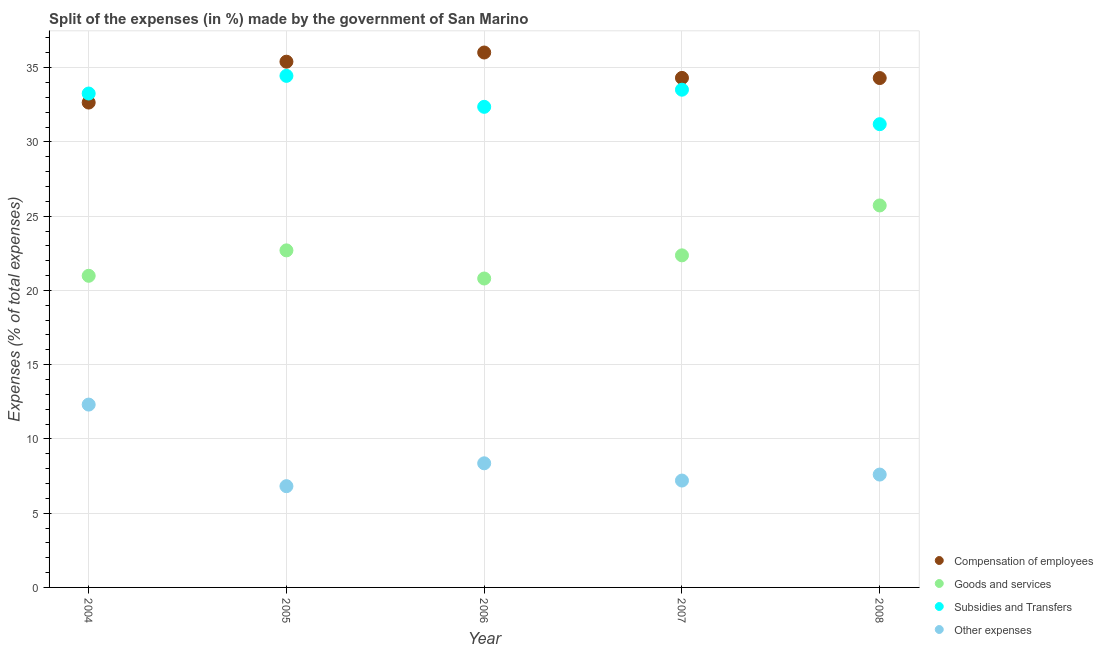How many different coloured dotlines are there?
Provide a succinct answer. 4. Is the number of dotlines equal to the number of legend labels?
Your answer should be very brief. Yes. What is the percentage of amount spent on goods and services in 2008?
Your answer should be very brief. 25.72. Across all years, what is the maximum percentage of amount spent on subsidies?
Ensure brevity in your answer.  34.45. Across all years, what is the minimum percentage of amount spent on subsidies?
Offer a terse response. 31.19. In which year was the percentage of amount spent on other expenses maximum?
Offer a terse response. 2004. What is the total percentage of amount spent on compensation of employees in the graph?
Your answer should be very brief. 172.68. What is the difference between the percentage of amount spent on goods and services in 2006 and that in 2007?
Your answer should be very brief. -1.56. What is the difference between the percentage of amount spent on other expenses in 2004 and the percentage of amount spent on compensation of employees in 2005?
Ensure brevity in your answer.  -23.09. What is the average percentage of amount spent on other expenses per year?
Offer a very short reply. 8.46. In the year 2006, what is the difference between the percentage of amount spent on subsidies and percentage of amount spent on compensation of employees?
Offer a terse response. -3.66. What is the ratio of the percentage of amount spent on compensation of employees in 2007 to that in 2008?
Give a very brief answer. 1. Is the percentage of amount spent on goods and services in 2005 less than that in 2008?
Offer a very short reply. Yes. Is the difference between the percentage of amount spent on other expenses in 2004 and 2007 greater than the difference between the percentage of amount spent on subsidies in 2004 and 2007?
Your answer should be very brief. Yes. What is the difference between the highest and the second highest percentage of amount spent on compensation of employees?
Give a very brief answer. 0.62. What is the difference between the highest and the lowest percentage of amount spent on other expenses?
Offer a terse response. 5.49. Is the sum of the percentage of amount spent on compensation of employees in 2005 and 2006 greater than the maximum percentage of amount spent on goods and services across all years?
Ensure brevity in your answer.  Yes. Is it the case that in every year, the sum of the percentage of amount spent on other expenses and percentage of amount spent on subsidies is greater than the sum of percentage of amount spent on goods and services and percentage of amount spent on compensation of employees?
Keep it short and to the point. No. Does the percentage of amount spent on other expenses monotonically increase over the years?
Keep it short and to the point. No. Is the percentage of amount spent on goods and services strictly greater than the percentage of amount spent on subsidies over the years?
Provide a short and direct response. No. Is the percentage of amount spent on goods and services strictly less than the percentage of amount spent on other expenses over the years?
Offer a terse response. No. Are the values on the major ticks of Y-axis written in scientific E-notation?
Your answer should be compact. No. Does the graph contain any zero values?
Offer a very short reply. No. Does the graph contain grids?
Keep it short and to the point. Yes. What is the title of the graph?
Your answer should be compact. Split of the expenses (in %) made by the government of San Marino. What is the label or title of the X-axis?
Your answer should be very brief. Year. What is the label or title of the Y-axis?
Your answer should be compact. Expenses (% of total expenses). What is the Expenses (% of total expenses) of Compensation of employees in 2004?
Offer a very short reply. 32.65. What is the Expenses (% of total expenses) of Goods and services in 2004?
Your answer should be compact. 20.98. What is the Expenses (% of total expenses) of Subsidies and Transfers in 2004?
Offer a terse response. 33.26. What is the Expenses (% of total expenses) of Other expenses in 2004?
Your answer should be very brief. 12.31. What is the Expenses (% of total expenses) in Compensation of employees in 2005?
Make the answer very short. 35.4. What is the Expenses (% of total expenses) in Goods and services in 2005?
Provide a succinct answer. 22.7. What is the Expenses (% of total expenses) in Subsidies and Transfers in 2005?
Offer a terse response. 34.45. What is the Expenses (% of total expenses) of Other expenses in 2005?
Your response must be concise. 6.82. What is the Expenses (% of total expenses) of Compensation of employees in 2006?
Provide a succinct answer. 36.02. What is the Expenses (% of total expenses) in Goods and services in 2006?
Offer a terse response. 20.8. What is the Expenses (% of total expenses) of Subsidies and Transfers in 2006?
Provide a succinct answer. 32.36. What is the Expenses (% of total expenses) of Other expenses in 2006?
Your answer should be very brief. 8.36. What is the Expenses (% of total expenses) of Compensation of employees in 2007?
Make the answer very short. 34.31. What is the Expenses (% of total expenses) in Goods and services in 2007?
Provide a short and direct response. 22.36. What is the Expenses (% of total expenses) of Subsidies and Transfers in 2007?
Keep it short and to the point. 33.51. What is the Expenses (% of total expenses) of Other expenses in 2007?
Offer a very short reply. 7.2. What is the Expenses (% of total expenses) of Compensation of employees in 2008?
Give a very brief answer. 34.3. What is the Expenses (% of total expenses) of Goods and services in 2008?
Your answer should be very brief. 25.72. What is the Expenses (% of total expenses) of Subsidies and Transfers in 2008?
Ensure brevity in your answer.  31.19. What is the Expenses (% of total expenses) of Other expenses in 2008?
Your answer should be compact. 7.6. Across all years, what is the maximum Expenses (% of total expenses) of Compensation of employees?
Provide a succinct answer. 36.02. Across all years, what is the maximum Expenses (% of total expenses) in Goods and services?
Ensure brevity in your answer.  25.72. Across all years, what is the maximum Expenses (% of total expenses) in Subsidies and Transfers?
Make the answer very short. 34.45. Across all years, what is the maximum Expenses (% of total expenses) in Other expenses?
Offer a terse response. 12.31. Across all years, what is the minimum Expenses (% of total expenses) in Compensation of employees?
Your answer should be very brief. 32.65. Across all years, what is the minimum Expenses (% of total expenses) in Goods and services?
Give a very brief answer. 20.8. Across all years, what is the minimum Expenses (% of total expenses) of Subsidies and Transfers?
Keep it short and to the point. 31.19. Across all years, what is the minimum Expenses (% of total expenses) in Other expenses?
Offer a terse response. 6.82. What is the total Expenses (% of total expenses) in Compensation of employees in the graph?
Provide a succinct answer. 172.68. What is the total Expenses (% of total expenses) of Goods and services in the graph?
Give a very brief answer. 112.56. What is the total Expenses (% of total expenses) in Subsidies and Transfers in the graph?
Provide a succinct answer. 164.77. What is the total Expenses (% of total expenses) in Other expenses in the graph?
Your response must be concise. 42.28. What is the difference between the Expenses (% of total expenses) in Compensation of employees in 2004 and that in 2005?
Your answer should be very brief. -2.75. What is the difference between the Expenses (% of total expenses) in Goods and services in 2004 and that in 2005?
Your answer should be compact. -1.71. What is the difference between the Expenses (% of total expenses) in Subsidies and Transfers in 2004 and that in 2005?
Keep it short and to the point. -1.19. What is the difference between the Expenses (% of total expenses) of Other expenses in 2004 and that in 2005?
Ensure brevity in your answer.  5.49. What is the difference between the Expenses (% of total expenses) of Compensation of employees in 2004 and that in 2006?
Your response must be concise. -3.37. What is the difference between the Expenses (% of total expenses) in Goods and services in 2004 and that in 2006?
Your answer should be very brief. 0.18. What is the difference between the Expenses (% of total expenses) in Subsidies and Transfers in 2004 and that in 2006?
Your response must be concise. 0.9. What is the difference between the Expenses (% of total expenses) of Other expenses in 2004 and that in 2006?
Provide a succinct answer. 3.95. What is the difference between the Expenses (% of total expenses) in Compensation of employees in 2004 and that in 2007?
Give a very brief answer. -1.66. What is the difference between the Expenses (% of total expenses) in Goods and services in 2004 and that in 2007?
Your response must be concise. -1.38. What is the difference between the Expenses (% of total expenses) of Subsidies and Transfers in 2004 and that in 2007?
Your answer should be compact. -0.26. What is the difference between the Expenses (% of total expenses) in Other expenses in 2004 and that in 2007?
Your response must be concise. 5.12. What is the difference between the Expenses (% of total expenses) of Compensation of employees in 2004 and that in 2008?
Provide a succinct answer. -1.65. What is the difference between the Expenses (% of total expenses) of Goods and services in 2004 and that in 2008?
Provide a succinct answer. -4.74. What is the difference between the Expenses (% of total expenses) in Subsidies and Transfers in 2004 and that in 2008?
Offer a terse response. 2.06. What is the difference between the Expenses (% of total expenses) of Other expenses in 2004 and that in 2008?
Offer a terse response. 4.71. What is the difference between the Expenses (% of total expenses) in Compensation of employees in 2005 and that in 2006?
Provide a short and direct response. -0.62. What is the difference between the Expenses (% of total expenses) in Goods and services in 2005 and that in 2006?
Offer a very short reply. 1.89. What is the difference between the Expenses (% of total expenses) in Subsidies and Transfers in 2005 and that in 2006?
Your answer should be very brief. 2.08. What is the difference between the Expenses (% of total expenses) of Other expenses in 2005 and that in 2006?
Provide a succinct answer. -1.54. What is the difference between the Expenses (% of total expenses) in Compensation of employees in 2005 and that in 2007?
Offer a very short reply. 1.09. What is the difference between the Expenses (% of total expenses) in Goods and services in 2005 and that in 2007?
Make the answer very short. 0.34. What is the difference between the Expenses (% of total expenses) of Subsidies and Transfers in 2005 and that in 2007?
Keep it short and to the point. 0.93. What is the difference between the Expenses (% of total expenses) in Other expenses in 2005 and that in 2007?
Offer a terse response. -0.38. What is the difference between the Expenses (% of total expenses) in Compensation of employees in 2005 and that in 2008?
Give a very brief answer. 1.1. What is the difference between the Expenses (% of total expenses) of Goods and services in 2005 and that in 2008?
Ensure brevity in your answer.  -3.02. What is the difference between the Expenses (% of total expenses) in Subsidies and Transfers in 2005 and that in 2008?
Offer a very short reply. 3.25. What is the difference between the Expenses (% of total expenses) of Other expenses in 2005 and that in 2008?
Your answer should be compact. -0.78. What is the difference between the Expenses (% of total expenses) of Compensation of employees in 2006 and that in 2007?
Make the answer very short. 1.71. What is the difference between the Expenses (% of total expenses) in Goods and services in 2006 and that in 2007?
Ensure brevity in your answer.  -1.56. What is the difference between the Expenses (% of total expenses) of Subsidies and Transfers in 2006 and that in 2007?
Your answer should be compact. -1.15. What is the difference between the Expenses (% of total expenses) in Other expenses in 2006 and that in 2007?
Ensure brevity in your answer.  1.16. What is the difference between the Expenses (% of total expenses) of Compensation of employees in 2006 and that in 2008?
Provide a succinct answer. 1.72. What is the difference between the Expenses (% of total expenses) in Goods and services in 2006 and that in 2008?
Provide a short and direct response. -4.92. What is the difference between the Expenses (% of total expenses) of Subsidies and Transfers in 2006 and that in 2008?
Your answer should be very brief. 1.17. What is the difference between the Expenses (% of total expenses) in Other expenses in 2006 and that in 2008?
Your response must be concise. 0.76. What is the difference between the Expenses (% of total expenses) of Compensation of employees in 2007 and that in 2008?
Ensure brevity in your answer.  0.01. What is the difference between the Expenses (% of total expenses) in Goods and services in 2007 and that in 2008?
Your response must be concise. -3.36. What is the difference between the Expenses (% of total expenses) of Subsidies and Transfers in 2007 and that in 2008?
Give a very brief answer. 2.32. What is the difference between the Expenses (% of total expenses) of Other expenses in 2007 and that in 2008?
Give a very brief answer. -0.4. What is the difference between the Expenses (% of total expenses) of Compensation of employees in 2004 and the Expenses (% of total expenses) of Goods and services in 2005?
Ensure brevity in your answer.  9.95. What is the difference between the Expenses (% of total expenses) of Compensation of employees in 2004 and the Expenses (% of total expenses) of Subsidies and Transfers in 2005?
Give a very brief answer. -1.8. What is the difference between the Expenses (% of total expenses) of Compensation of employees in 2004 and the Expenses (% of total expenses) of Other expenses in 2005?
Your answer should be very brief. 25.83. What is the difference between the Expenses (% of total expenses) of Goods and services in 2004 and the Expenses (% of total expenses) of Subsidies and Transfers in 2005?
Make the answer very short. -13.46. What is the difference between the Expenses (% of total expenses) of Goods and services in 2004 and the Expenses (% of total expenses) of Other expenses in 2005?
Give a very brief answer. 14.17. What is the difference between the Expenses (% of total expenses) in Subsidies and Transfers in 2004 and the Expenses (% of total expenses) in Other expenses in 2005?
Provide a succinct answer. 26.44. What is the difference between the Expenses (% of total expenses) in Compensation of employees in 2004 and the Expenses (% of total expenses) in Goods and services in 2006?
Provide a short and direct response. 11.85. What is the difference between the Expenses (% of total expenses) in Compensation of employees in 2004 and the Expenses (% of total expenses) in Subsidies and Transfers in 2006?
Your response must be concise. 0.29. What is the difference between the Expenses (% of total expenses) of Compensation of employees in 2004 and the Expenses (% of total expenses) of Other expenses in 2006?
Your answer should be compact. 24.29. What is the difference between the Expenses (% of total expenses) in Goods and services in 2004 and the Expenses (% of total expenses) in Subsidies and Transfers in 2006?
Your answer should be very brief. -11.38. What is the difference between the Expenses (% of total expenses) of Goods and services in 2004 and the Expenses (% of total expenses) of Other expenses in 2006?
Offer a very short reply. 12.63. What is the difference between the Expenses (% of total expenses) of Subsidies and Transfers in 2004 and the Expenses (% of total expenses) of Other expenses in 2006?
Your answer should be very brief. 24.9. What is the difference between the Expenses (% of total expenses) in Compensation of employees in 2004 and the Expenses (% of total expenses) in Goods and services in 2007?
Provide a short and direct response. 10.29. What is the difference between the Expenses (% of total expenses) in Compensation of employees in 2004 and the Expenses (% of total expenses) in Subsidies and Transfers in 2007?
Provide a short and direct response. -0.87. What is the difference between the Expenses (% of total expenses) of Compensation of employees in 2004 and the Expenses (% of total expenses) of Other expenses in 2007?
Make the answer very short. 25.45. What is the difference between the Expenses (% of total expenses) of Goods and services in 2004 and the Expenses (% of total expenses) of Subsidies and Transfers in 2007?
Your answer should be very brief. -12.53. What is the difference between the Expenses (% of total expenses) of Goods and services in 2004 and the Expenses (% of total expenses) of Other expenses in 2007?
Your answer should be very brief. 13.79. What is the difference between the Expenses (% of total expenses) in Subsidies and Transfers in 2004 and the Expenses (% of total expenses) in Other expenses in 2007?
Provide a short and direct response. 26.06. What is the difference between the Expenses (% of total expenses) in Compensation of employees in 2004 and the Expenses (% of total expenses) in Goods and services in 2008?
Make the answer very short. 6.93. What is the difference between the Expenses (% of total expenses) of Compensation of employees in 2004 and the Expenses (% of total expenses) of Subsidies and Transfers in 2008?
Your answer should be very brief. 1.46. What is the difference between the Expenses (% of total expenses) of Compensation of employees in 2004 and the Expenses (% of total expenses) of Other expenses in 2008?
Give a very brief answer. 25.05. What is the difference between the Expenses (% of total expenses) in Goods and services in 2004 and the Expenses (% of total expenses) in Subsidies and Transfers in 2008?
Give a very brief answer. -10.21. What is the difference between the Expenses (% of total expenses) of Goods and services in 2004 and the Expenses (% of total expenses) of Other expenses in 2008?
Your response must be concise. 13.38. What is the difference between the Expenses (% of total expenses) of Subsidies and Transfers in 2004 and the Expenses (% of total expenses) of Other expenses in 2008?
Your answer should be compact. 25.66. What is the difference between the Expenses (% of total expenses) in Compensation of employees in 2005 and the Expenses (% of total expenses) in Goods and services in 2006?
Give a very brief answer. 14.6. What is the difference between the Expenses (% of total expenses) in Compensation of employees in 2005 and the Expenses (% of total expenses) in Subsidies and Transfers in 2006?
Offer a very short reply. 3.04. What is the difference between the Expenses (% of total expenses) of Compensation of employees in 2005 and the Expenses (% of total expenses) of Other expenses in 2006?
Your response must be concise. 27.04. What is the difference between the Expenses (% of total expenses) in Goods and services in 2005 and the Expenses (% of total expenses) in Subsidies and Transfers in 2006?
Your answer should be very brief. -9.67. What is the difference between the Expenses (% of total expenses) in Goods and services in 2005 and the Expenses (% of total expenses) in Other expenses in 2006?
Offer a very short reply. 14.34. What is the difference between the Expenses (% of total expenses) in Subsidies and Transfers in 2005 and the Expenses (% of total expenses) in Other expenses in 2006?
Give a very brief answer. 26.09. What is the difference between the Expenses (% of total expenses) in Compensation of employees in 2005 and the Expenses (% of total expenses) in Goods and services in 2007?
Make the answer very short. 13.04. What is the difference between the Expenses (% of total expenses) of Compensation of employees in 2005 and the Expenses (% of total expenses) of Subsidies and Transfers in 2007?
Keep it short and to the point. 1.89. What is the difference between the Expenses (% of total expenses) of Compensation of employees in 2005 and the Expenses (% of total expenses) of Other expenses in 2007?
Offer a very short reply. 28.2. What is the difference between the Expenses (% of total expenses) in Goods and services in 2005 and the Expenses (% of total expenses) in Subsidies and Transfers in 2007?
Give a very brief answer. -10.82. What is the difference between the Expenses (% of total expenses) in Goods and services in 2005 and the Expenses (% of total expenses) in Other expenses in 2007?
Give a very brief answer. 15.5. What is the difference between the Expenses (% of total expenses) of Subsidies and Transfers in 2005 and the Expenses (% of total expenses) of Other expenses in 2007?
Your answer should be compact. 27.25. What is the difference between the Expenses (% of total expenses) of Compensation of employees in 2005 and the Expenses (% of total expenses) of Goods and services in 2008?
Ensure brevity in your answer.  9.68. What is the difference between the Expenses (% of total expenses) of Compensation of employees in 2005 and the Expenses (% of total expenses) of Subsidies and Transfers in 2008?
Your answer should be compact. 4.21. What is the difference between the Expenses (% of total expenses) in Compensation of employees in 2005 and the Expenses (% of total expenses) in Other expenses in 2008?
Ensure brevity in your answer.  27.8. What is the difference between the Expenses (% of total expenses) in Goods and services in 2005 and the Expenses (% of total expenses) in Subsidies and Transfers in 2008?
Your answer should be compact. -8.5. What is the difference between the Expenses (% of total expenses) of Goods and services in 2005 and the Expenses (% of total expenses) of Other expenses in 2008?
Your answer should be compact. 15.1. What is the difference between the Expenses (% of total expenses) of Subsidies and Transfers in 2005 and the Expenses (% of total expenses) of Other expenses in 2008?
Offer a terse response. 26.85. What is the difference between the Expenses (% of total expenses) of Compensation of employees in 2006 and the Expenses (% of total expenses) of Goods and services in 2007?
Offer a very short reply. 13.66. What is the difference between the Expenses (% of total expenses) of Compensation of employees in 2006 and the Expenses (% of total expenses) of Subsidies and Transfers in 2007?
Offer a very short reply. 2.5. What is the difference between the Expenses (% of total expenses) of Compensation of employees in 2006 and the Expenses (% of total expenses) of Other expenses in 2007?
Offer a very short reply. 28.82. What is the difference between the Expenses (% of total expenses) of Goods and services in 2006 and the Expenses (% of total expenses) of Subsidies and Transfers in 2007?
Offer a very short reply. -12.71. What is the difference between the Expenses (% of total expenses) in Goods and services in 2006 and the Expenses (% of total expenses) in Other expenses in 2007?
Give a very brief answer. 13.6. What is the difference between the Expenses (% of total expenses) in Subsidies and Transfers in 2006 and the Expenses (% of total expenses) in Other expenses in 2007?
Your answer should be compact. 25.16. What is the difference between the Expenses (% of total expenses) of Compensation of employees in 2006 and the Expenses (% of total expenses) of Goods and services in 2008?
Your answer should be very brief. 10.3. What is the difference between the Expenses (% of total expenses) in Compensation of employees in 2006 and the Expenses (% of total expenses) in Subsidies and Transfers in 2008?
Give a very brief answer. 4.83. What is the difference between the Expenses (% of total expenses) in Compensation of employees in 2006 and the Expenses (% of total expenses) in Other expenses in 2008?
Provide a short and direct response. 28.42. What is the difference between the Expenses (% of total expenses) in Goods and services in 2006 and the Expenses (% of total expenses) in Subsidies and Transfers in 2008?
Provide a succinct answer. -10.39. What is the difference between the Expenses (% of total expenses) of Goods and services in 2006 and the Expenses (% of total expenses) of Other expenses in 2008?
Your answer should be compact. 13.2. What is the difference between the Expenses (% of total expenses) of Subsidies and Transfers in 2006 and the Expenses (% of total expenses) of Other expenses in 2008?
Ensure brevity in your answer.  24.76. What is the difference between the Expenses (% of total expenses) of Compensation of employees in 2007 and the Expenses (% of total expenses) of Goods and services in 2008?
Make the answer very short. 8.59. What is the difference between the Expenses (% of total expenses) in Compensation of employees in 2007 and the Expenses (% of total expenses) in Subsidies and Transfers in 2008?
Ensure brevity in your answer.  3.12. What is the difference between the Expenses (% of total expenses) of Compensation of employees in 2007 and the Expenses (% of total expenses) of Other expenses in 2008?
Keep it short and to the point. 26.71. What is the difference between the Expenses (% of total expenses) of Goods and services in 2007 and the Expenses (% of total expenses) of Subsidies and Transfers in 2008?
Offer a very short reply. -8.83. What is the difference between the Expenses (% of total expenses) of Goods and services in 2007 and the Expenses (% of total expenses) of Other expenses in 2008?
Give a very brief answer. 14.76. What is the difference between the Expenses (% of total expenses) of Subsidies and Transfers in 2007 and the Expenses (% of total expenses) of Other expenses in 2008?
Ensure brevity in your answer.  25.91. What is the average Expenses (% of total expenses) of Compensation of employees per year?
Provide a short and direct response. 34.54. What is the average Expenses (% of total expenses) of Goods and services per year?
Keep it short and to the point. 22.51. What is the average Expenses (% of total expenses) of Subsidies and Transfers per year?
Your answer should be very brief. 32.95. What is the average Expenses (% of total expenses) in Other expenses per year?
Ensure brevity in your answer.  8.46. In the year 2004, what is the difference between the Expenses (% of total expenses) of Compensation of employees and Expenses (% of total expenses) of Goods and services?
Your response must be concise. 11.66. In the year 2004, what is the difference between the Expenses (% of total expenses) in Compensation of employees and Expenses (% of total expenses) in Subsidies and Transfers?
Give a very brief answer. -0.61. In the year 2004, what is the difference between the Expenses (% of total expenses) in Compensation of employees and Expenses (% of total expenses) in Other expenses?
Make the answer very short. 20.34. In the year 2004, what is the difference between the Expenses (% of total expenses) in Goods and services and Expenses (% of total expenses) in Subsidies and Transfers?
Provide a succinct answer. -12.27. In the year 2004, what is the difference between the Expenses (% of total expenses) of Goods and services and Expenses (% of total expenses) of Other expenses?
Offer a terse response. 8.67. In the year 2004, what is the difference between the Expenses (% of total expenses) of Subsidies and Transfers and Expenses (% of total expenses) of Other expenses?
Your answer should be very brief. 20.95. In the year 2005, what is the difference between the Expenses (% of total expenses) of Compensation of employees and Expenses (% of total expenses) of Goods and services?
Provide a short and direct response. 12.7. In the year 2005, what is the difference between the Expenses (% of total expenses) in Compensation of employees and Expenses (% of total expenses) in Subsidies and Transfers?
Provide a succinct answer. 0.95. In the year 2005, what is the difference between the Expenses (% of total expenses) of Compensation of employees and Expenses (% of total expenses) of Other expenses?
Your answer should be compact. 28.58. In the year 2005, what is the difference between the Expenses (% of total expenses) in Goods and services and Expenses (% of total expenses) in Subsidies and Transfers?
Offer a terse response. -11.75. In the year 2005, what is the difference between the Expenses (% of total expenses) in Goods and services and Expenses (% of total expenses) in Other expenses?
Ensure brevity in your answer.  15.88. In the year 2005, what is the difference between the Expenses (% of total expenses) of Subsidies and Transfers and Expenses (% of total expenses) of Other expenses?
Ensure brevity in your answer.  27.63. In the year 2006, what is the difference between the Expenses (% of total expenses) of Compensation of employees and Expenses (% of total expenses) of Goods and services?
Your answer should be very brief. 15.22. In the year 2006, what is the difference between the Expenses (% of total expenses) in Compensation of employees and Expenses (% of total expenses) in Subsidies and Transfers?
Your answer should be very brief. 3.66. In the year 2006, what is the difference between the Expenses (% of total expenses) of Compensation of employees and Expenses (% of total expenses) of Other expenses?
Provide a succinct answer. 27.66. In the year 2006, what is the difference between the Expenses (% of total expenses) of Goods and services and Expenses (% of total expenses) of Subsidies and Transfers?
Your answer should be very brief. -11.56. In the year 2006, what is the difference between the Expenses (% of total expenses) of Goods and services and Expenses (% of total expenses) of Other expenses?
Provide a succinct answer. 12.44. In the year 2006, what is the difference between the Expenses (% of total expenses) of Subsidies and Transfers and Expenses (% of total expenses) of Other expenses?
Your answer should be compact. 24. In the year 2007, what is the difference between the Expenses (% of total expenses) in Compensation of employees and Expenses (% of total expenses) in Goods and services?
Your response must be concise. 11.95. In the year 2007, what is the difference between the Expenses (% of total expenses) in Compensation of employees and Expenses (% of total expenses) in Subsidies and Transfers?
Your answer should be compact. 0.8. In the year 2007, what is the difference between the Expenses (% of total expenses) of Compensation of employees and Expenses (% of total expenses) of Other expenses?
Provide a succinct answer. 27.11. In the year 2007, what is the difference between the Expenses (% of total expenses) in Goods and services and Expenses (% of total expenses) in Subsidies and Transfers?
Offer a terse response. -11.15. In the year 2007, what is the difference between the Expenses (% of total expenses) in Goods and services and Expenses (% of total expenses) in Other expenses?
Give a very brief answer. 15.16. In the year 2007, what is the difference between the Expenses (% of total expenses) in Subsidies and Transfers and Expenses (% of total expenses) in Other expenses?
Offer a terse response. 26.32. In the year 2008, what is the difference between the Expenses (% of total expenses) in Compensation of employees and Expenses (% of total expenses) in Goods and services?
Keep it short and to the point. 8.58. In the year 2008, what is the difference between the Expenses (% of total expenses) in Compensation of employees and Expenses (% of total expenses) in Subsidies and Transfers?
Your response must be concise. 3.11. In the year 2008, what is the difference between the Expenses (% of total expenses) of Compensation of employees and Expenses (% of total expenses) of Other expenses?
Ensure brevity in your answer.  26.7. In the year 2008, what is the difference between the Expenses (% of total expenses) of Goods and services and Expenses (% of total expenses) of Subsidies and Transfers?
Your answer should be very brief. -5.47. In the year 2008, what is the difference between the Expenses (% of total expenses) in Goods and services and Expenses (% of total expenses) in Other expenses?
Give a very brief answer. 18.12. In the year 2008, what is the difference between the Expenses (% of total expenses) of Subsidies and Transfers and Expenses (% of total expenses) of Other expenses?
Offer a very short reply. 23.59. What is the ratio of the Expenses (% of total expenses) in Compensation of employees in 2004 to that in 2005?
Provide a succinct answer. 0.92. What is the ratio of the Expenses (% of total expenses) in Goods and services in 2004 to that in 2005?
Offer a terse response. 0.92. What is the ratio of the Expenses (% of total expenses) in Subsidies and Transfers in 2004 to that in 2005?
Provide a short and direct response. 0.97. What is the ratio of the Expenses (% of total expenses) of Other expenses in 2004 to that in 2005?
Provide a succinct answer. 1.81. What is the ratio of the Expenses (% of total expenses) in Compensation of employees in 2004 to that in 2006?
Provide a short and direct response. 0.91. What is the ratio of the Expenses (% of total expenses) of Goods and services in 2004 to that in 2006?
Ensure brevity in your answer.  1.01. What is the ratio of the Expenses (% of total expenses) in Subsidies and Transfers in 2004 to that in 2006?
Your response must be concise. 1.03. What is the ratio of the Expenses (% of total expenses) in Other expenses in 2004 to that in 2006?
Make the answer very short. 1.47. What is the ratio of the Expenses (% of total expenses) in Compensation of employees in 2004 to that in 2007?
Your answer should be compact. 0.95. What is the ratio of the Expenses (% of total expenses) in Goods and services in 2004 to that in 2007?
Make the answer very short. 0.94. What is the ratio of the Expenses (% of total expenses) of Other expenses in 2004 to that in 2007?
Offer a very short reply. 1.71. What is the ratio of the Expenses (% of total expenses) of Compensation of employees in 2004 to that in 2008?
Your answer should be compact. 0.95. What is the ratio of the Expenses (% of total expenses) of Goods and services in 2004 to that in 2008?
Offer a very short reply. 0.82. What is the ratio of the Expenses (% of total expenses) in Subsidies and Transfers in 2004 to that in 2008?
Your response must be concise. 1.07. What is the ratio of the Expenses (% of total expenses) in Other expenses in 2004 to that in 2008?
Your answer should be compact. 1.62. What is the ratio of the Expenses (% of total expenses) in Compensation of employees in 2005 to that in 2006?
Offer a terse response. 0.98. What is the ratio of the Expenses (% of total expenses) of Goods and services in 2005 to that in 2006?
Your response must be concise. 1.09. What is the ratio of the Expenses (% of total expenses) in Subsidies and Transfers in 2005 to that in 2006?
Your answer should be compact. 1.06. What is the ratio of the Expenses (% of total expenses) in Other expenses in 2005 to that in 2006?
Make the answer very short. 0.82. What is the ratio of the Expenses (% of total expenses) in Compensation of employees in 2005 to that in 2007?
Offer a terse response. 1.03. What is the ratio of the Expenses (% of total expenses) in Goods and services in 2005 to that in 2007?
Provide a short and direct response. 1.01. What is the ratio of the Expenses (% of total expenses) in Subsidies and Transfers in 2005 to that in 2007?
Offer a very short reply. 1.03. What is the ratio of the Expenses (% of total expenses) in Compensation of employees in 2005 to that in 2008?
Offer a very short reply. 1.03. What is the ratio of the Expenses (% of total expenses) in Goods and services in 2005 to that in 2008?
Offer a terse response. 0.88. What is the ratio of the Expenses (% of total expenses) of Subsidies and Transfers in 2005 to that in 2008?
Your answer should be compact. 1.1. What is the ratio of the Expenses (% of total expenses) of Other expenses in 2005 to that in 2008?
Your answer should be very brief. 0.9. What is the ratio of the Expenses (% of total expenses) in Compensation of employees in 2006 to that in 2007?
Ensure brevity in your answer.  1.05. What is the ratio of the Expenses (% of total expenses) in Goods and services in 2006 to that in 2007?
Make the answer very short. 0.93. What is the ratio of the Expenses (% of total expenses) of Subsidies and Transfers in 2006 to that in 2007?
Make the answer very short. 0.97. What is the ratio of the Expenses (% of total expenses) of Other expenses in 2006 to that in 2007?
Ensure brevity in your answer.  1.16. What is the ratio of the Expenses (% of total expenses) in Compensation of employees in 2006 to that in 2008?
Your answer should be compact. 1.05. What is the ratio of the Expenses (% of total expenses) in Goods and services in 2006 to that in 2008?
Ensure brevity in your answer.  0.81. What is the ratio of the Expenses (% of total expenses) of Subsidies and Transfers in 2006 to that in 2008?
Make the answer very short. 1.04. What is the ratio of the Expenses (% of total expenses) of Other expenses in 2006 to that in 2008?
Your response must be concise. 1.1. What is the ratio of the Expenses (% of total expenses) in Compensation of employees in 2007 to that in 2008?
Offer a terse response. 1. What is the ratio of the Expenses (% of total expenses) of Goods and services in 2007 to that in 2008?
Provide a short and direct response. 0.87. What is the ratio of the Expenses (% of total expenses) of Subsidies and Transfers in 2007 to that in 2008?
Your answer should be compact. 1.07. What is the ratio of the Expenses (% of total expenses) in Other expenses in 2007 to that in 2008?
Provide a succinct answer. 0.95. What is the difference between the highest and the second highest Expenses (% of total expenses) of Compensation of employees?
Your response must be concise. 0.62. What is the difference between the highest and the second highest Expenses (% of total expenses) in Goods and services?
Give a very brief answer. 3.02. What is the difference between the highest and the second highest Expenses (% of total expenses) in Subsidies and Transfers?
Your answer should be compact. 0.93. What is the difference between the highest and the second highest Expenses (% of total expenses) in Other expenses?
Offer a very short reply. 3.95. What is the difference between the highest and the lowest Expenses (% of total expenses) in Compensation of employees?
Ensure brevity in your answer.  3.37. What is the difference between the highest and the lowest Expenses (% of total expenses) of Goods and services?
Your answer should be very brief. 4.92. What is the difference between the highest and the lowest Expenses (% of total expenses) of Subsidies and Transfers?
Ensure brevity in your answer.  3.25. What is the difference between the highest and the lowest Expenses (% of total expenses) of Other expenses?
Ensure brevity in your answer.  5.49. 